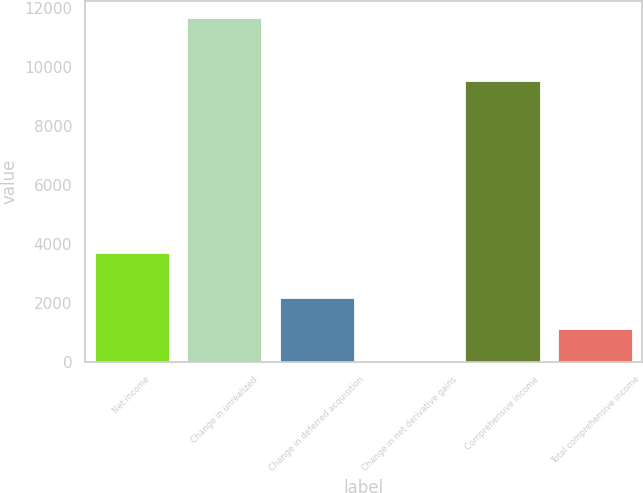Convert chart to OTSL. <chart><loc_0><loc_0><loc_500><loc_500><bar_chart><fcel>Net income<fcel>Change in unrealized<fcel>Change in deferred acquisition<fcel>Change in net derivative gains<fcel>Comprehensive income<fcel>Total comprehensive income<nl><fcel>3700<fcel>11666.4<fcel>2168.4<fcel>33<fcel>9531<fcel>1100.7<nl></chart> 